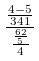Convert formula to latex. <formula><loc_0><loc_0><loc_500><loc_500>\frac { \frac { 4 - 5 } { 3 4 1 } } { \frac { \frac { 6 2 } { 5 } } { 4 } }</formula> 